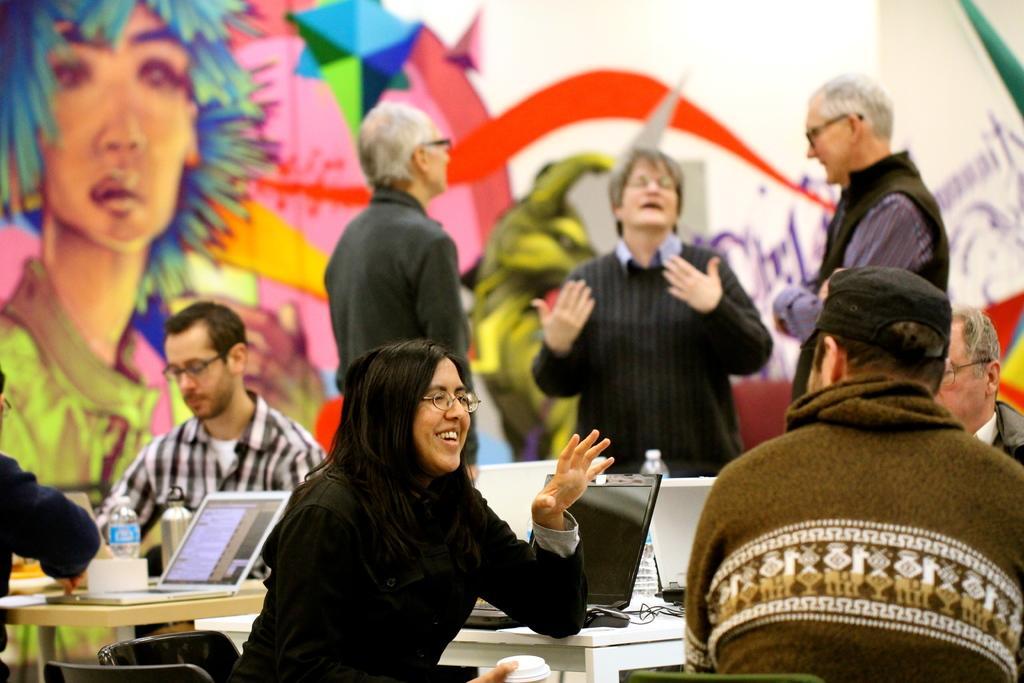Can you describe this image briefly? In this image there are 4 persons sitting in the chair near the table , and in table there are bottle, laptop, mouse, cable and in back ground there are 3 persons standing. 